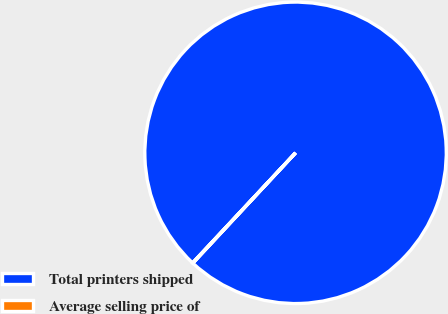Convert chart. <chart><loc_0><loc_0><loc_500><loc_500><pie_chart><fcel>Total printers shipped<fcel>Average selling price of<nl><fcel>99.96%<fcel>0.04%<nl></chart> 